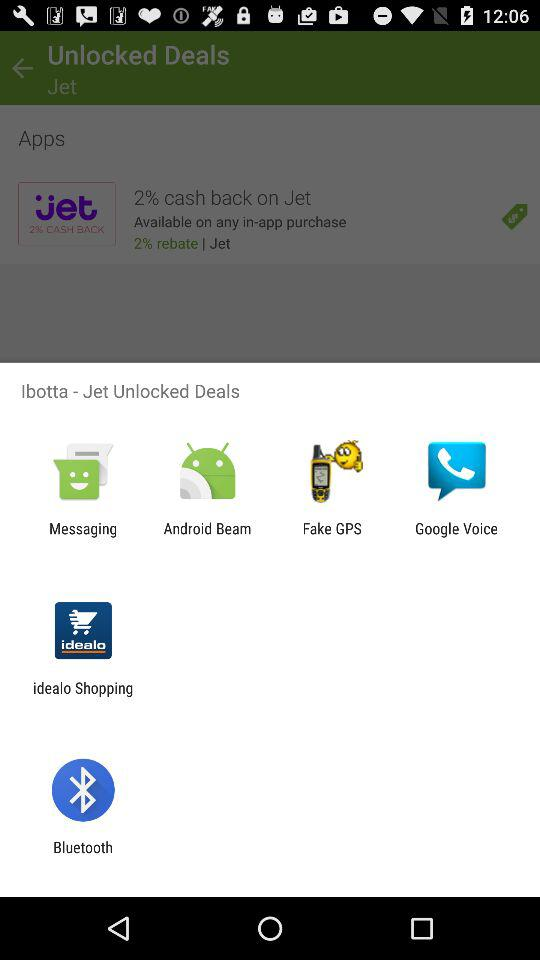When does the deal expire?
When the provided information is insufficient, respond with <no answer>. <no answer> 